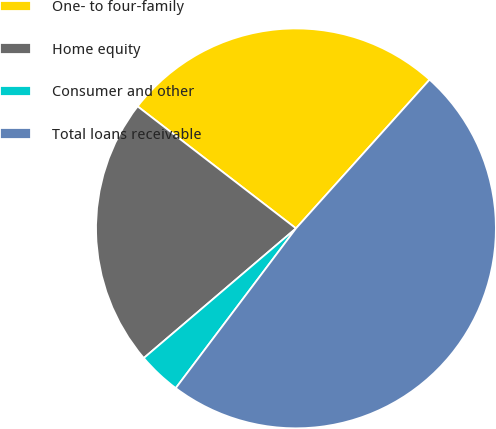Convert chart to OTSL. <chart><loc_0><loc_0><loc_500><loc_500><pie_chart><fcel>One- to four-family<fcel>Home equity<fcel>Consumer and other<fcel>Total loans receivable<nl><fcel>26.2%<fcel>21.68%<fcel>3.5%<fcel>48.62%<nl></chart> 